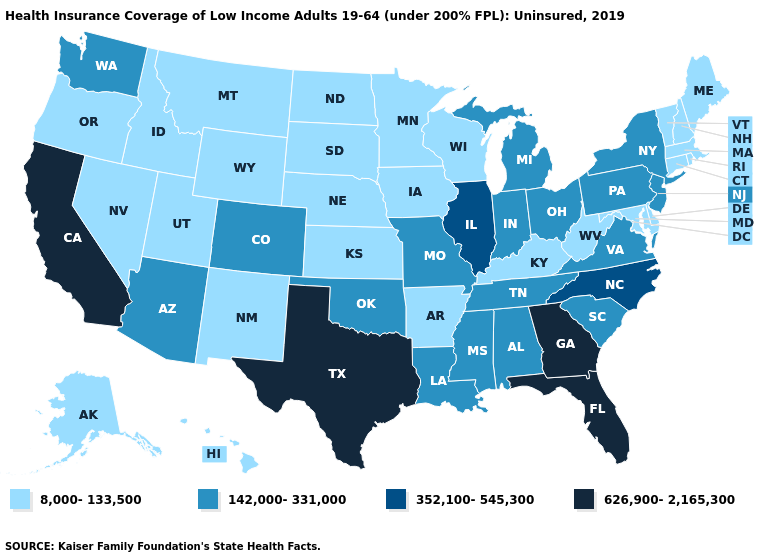Is the legend a continuous bar?
Answer briefly. No. Does the map have missing data?
Concise answer only. No. Name the states that have a value in the range 352,100-545,300?
Keep it brief. Illinois, North Carolina. Name the states that have a value in the range 8,000-133,500?
Quick response, please. Alaska, Arkansas, Connecticut, Delaware, Hawaii, Idaho, Iowa, Kansas, Kentucky, Maine, Maryland, Massachusetts, Minnesota, Montana, Nebraska, Nevada, New Hampshire, New Mexico, North Dakota, Oregon, Rhode Island, South Dakota, Utah, Vermont, West Virginia, Wisconsin, Wyoming. Which states hav the highest value in the West?
Quick response, please. California. Name the states that have a value in the range 626,900-2,165,300?
Be succinct. California, Florida, Georgia, Texas. What is the lowest value in the USA?
Quick response, please. 8,000-133,500. Among the states that border New Mexico , does Texas have the highest value?
Keep it brief. Yes. Is the legend a continuous bar?
Answer briefly. No. Does Louisiana have the lowest value in the USA?
Answer briefly. No. How many symbols are there in the legend?
Give a very brief answer. 4. What is the value of Tennessee?
Concise answer only. 142,000-331,000. How many symbols are there in the legend?
Short answer required. 4. Which states hav the highest value in the Northeast?
Short answer required. New Jersey, New York, Pennsylvania. Does Florida have the highest value in the USA?
Keep it brief. Yes. 